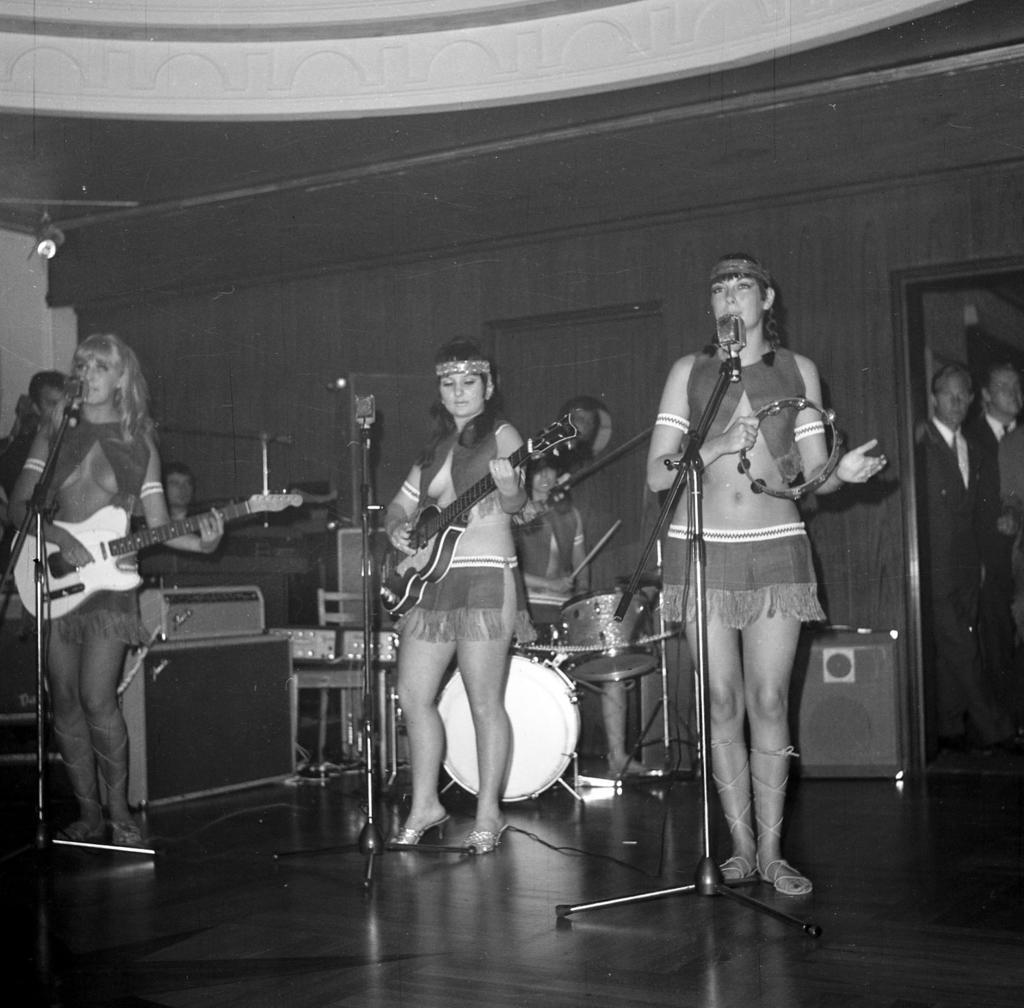How would you summarize this image in a sentence or two? As we can see in the image there is a wall, few people here. The women who are standing in the middle and in the left side are holding guitars and the women who is standing over here is singing song on mic. 